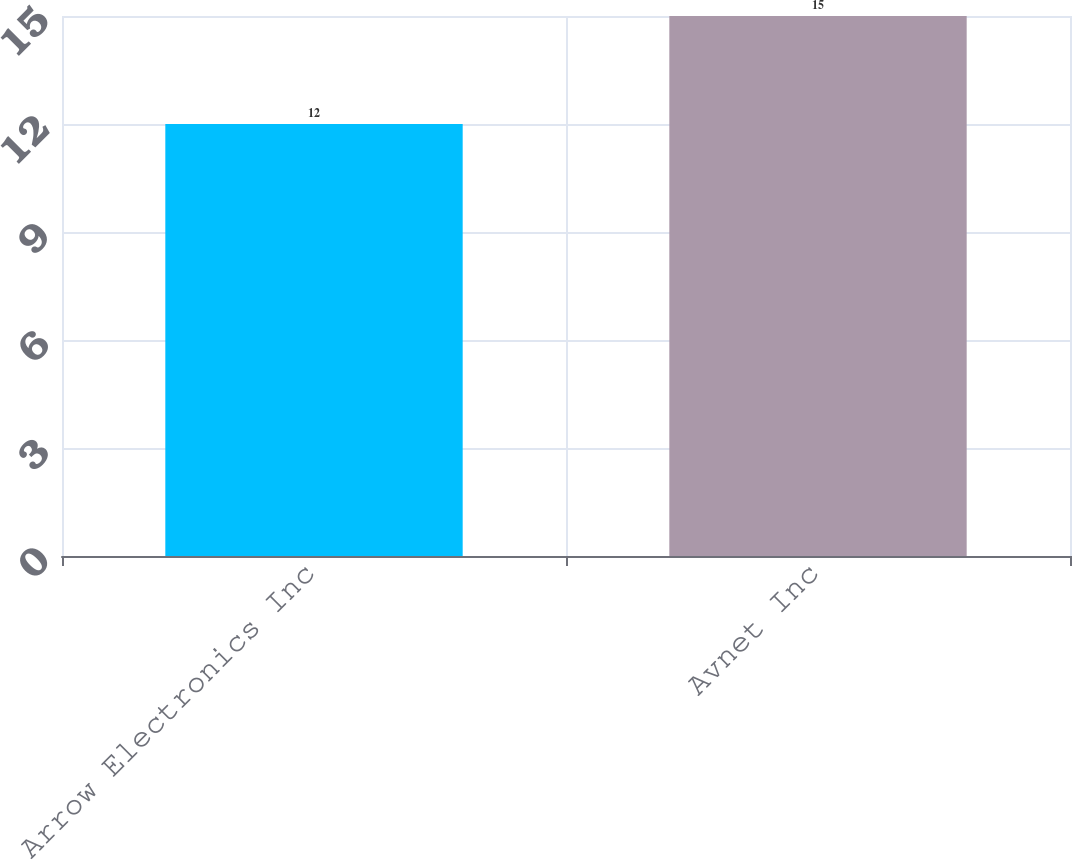Convert chart. <chart><loc_0><loc_0><loc_500><loc_500><bar_chart><fcel>Arrow Electronics Inc<fcel>Avnet Inc<nl><fcel>12<fcel>15<nl></chart> 